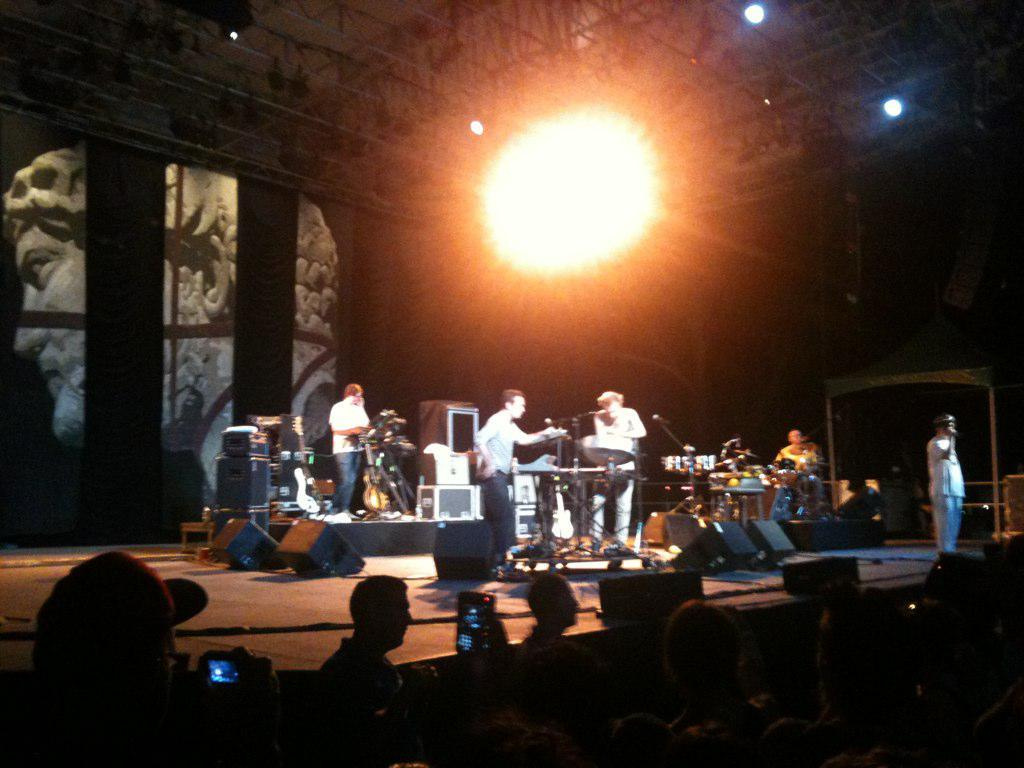What can be seen in the image that serves as a barrier or divider? There is a wall in the image. What can be seen in the image that provides illumination? There are lights in the image. What can be seen in the image that is used for capturing images or videos? There is a camera in the image. What can be seen in the image that suggests a gathering or event? There is a group of people in the image. What can be seen in the image that is used for holding or displaying items? There are tables in the image. What can be seen in the image that amplifies sound? There are sound boxes in the image. What can be seen in the image that is used for capturing or transmitting sound? There are microphones (mics) in the image. Where is the rat hiding in the image? There is no rat present in the image. What is the boy doing in the image? There is no boy present in the image. 